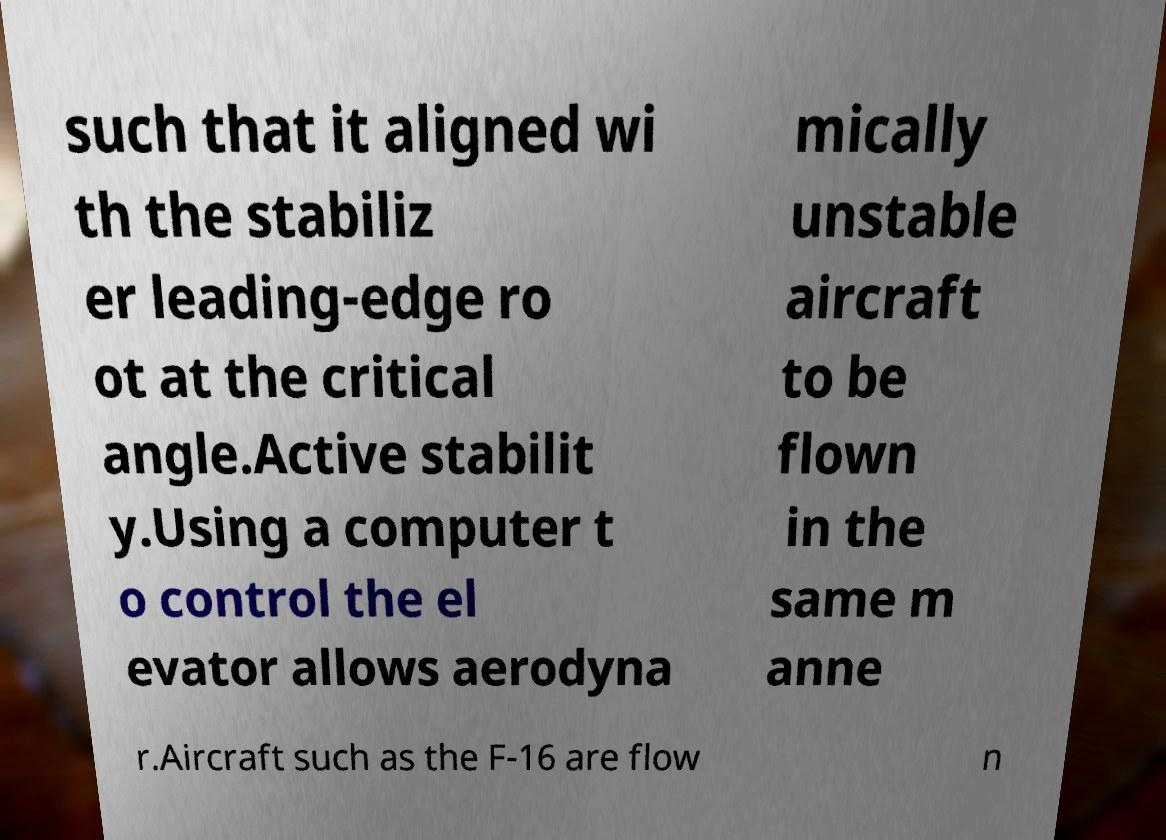I need the written content from this picture converted into text. Can you do that? such that it aligned wi th the stabiliz er leading-edge ro ot at the critical angle.Active stabilit y.Using a computer t o control the el evator allows aerodyna mically unstable aircraft to be flown in the same m anne r.Aircraft such as the F-16 are flow n 